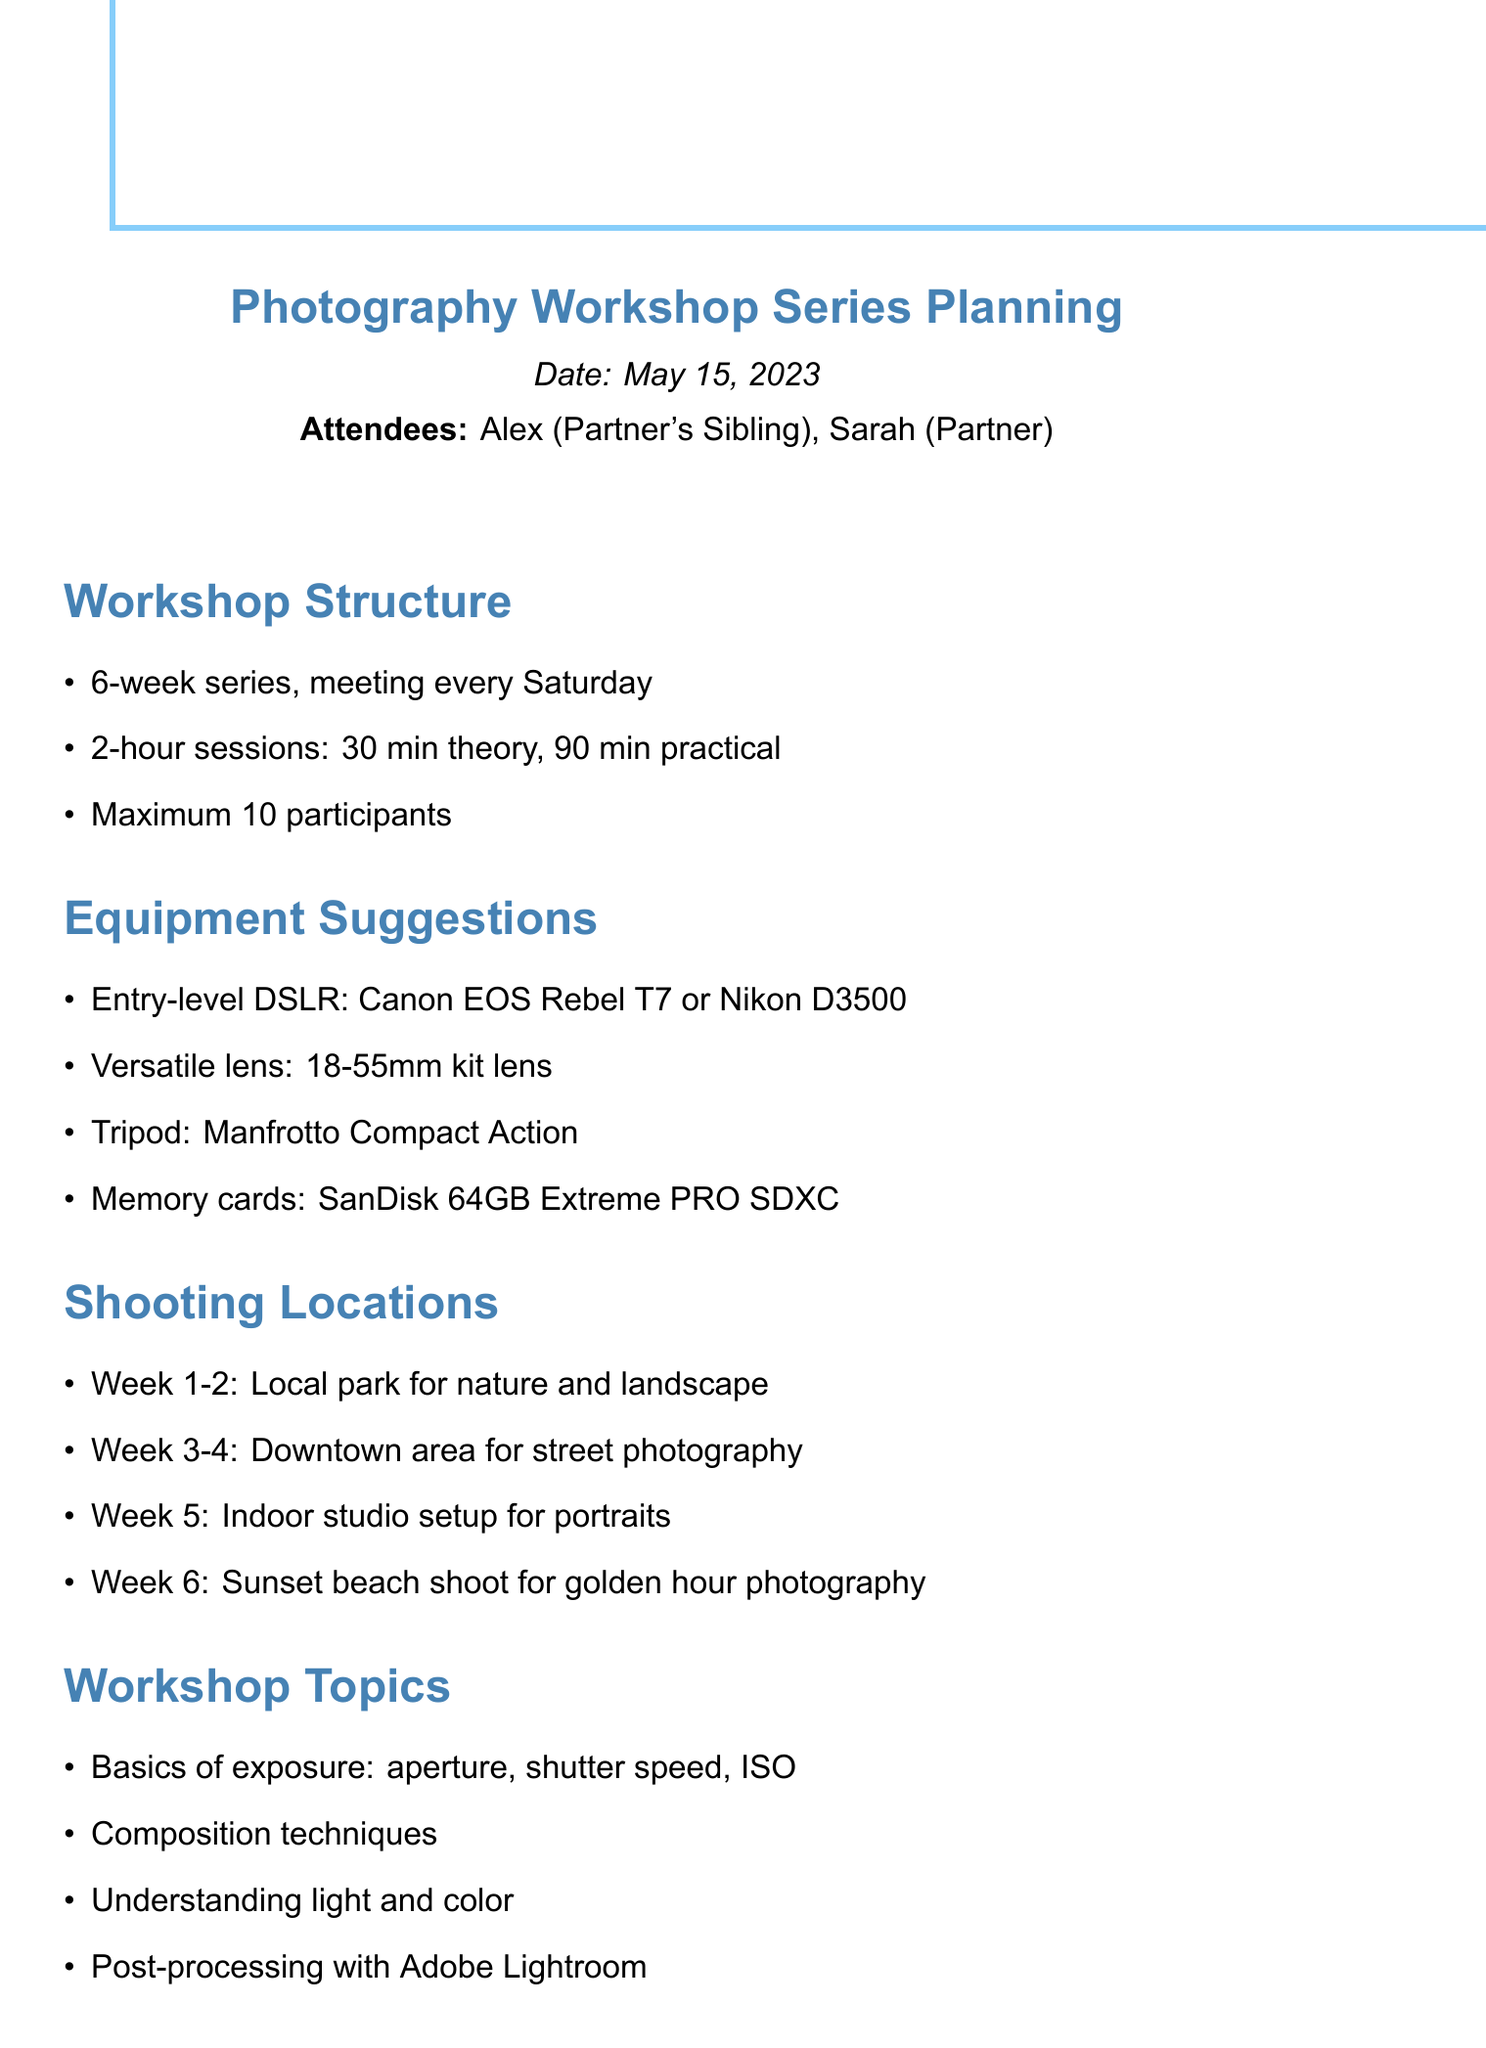What is the duration of the workshop series? The duration is specified as a 6-week series, meeting every Saturday.
Answer: 6 weeks What is the maximum number of participants allowed? The maximum participant limit is stated in the workshop structure section.
Answer: 10 participants Which camera models are suggested for beginners? The document lists specific camera models under equipment suggestions.
Answer: Canon EOS Rebel T7 or Nikon D3500 What will be the focus of Week 5's shooting location? The shooting location for Week 5 is designated for indoor activities, as noted in the document.
Answer: Indoor studio setup for portraits Who is responsible for creating the workshop outline? The document lists action items, specifying who will undertake specific tasks.
Answer: Alex What equipment is recommended for memory storage? Information regarding memory storage equipment is included in the equipment suggestions section.
Answer: SanDisk 64GB Extreme PRO SDXC Which session topics include post-processing techniques? The workshop topics list includes post-processing as a key subject area.
Answer: Post-processing with Adobe Lightroom What is the structure of each workshop session? The details of each session structure are specified in the workshop structure section.
Answer: 30 min theory, 90 min practical 